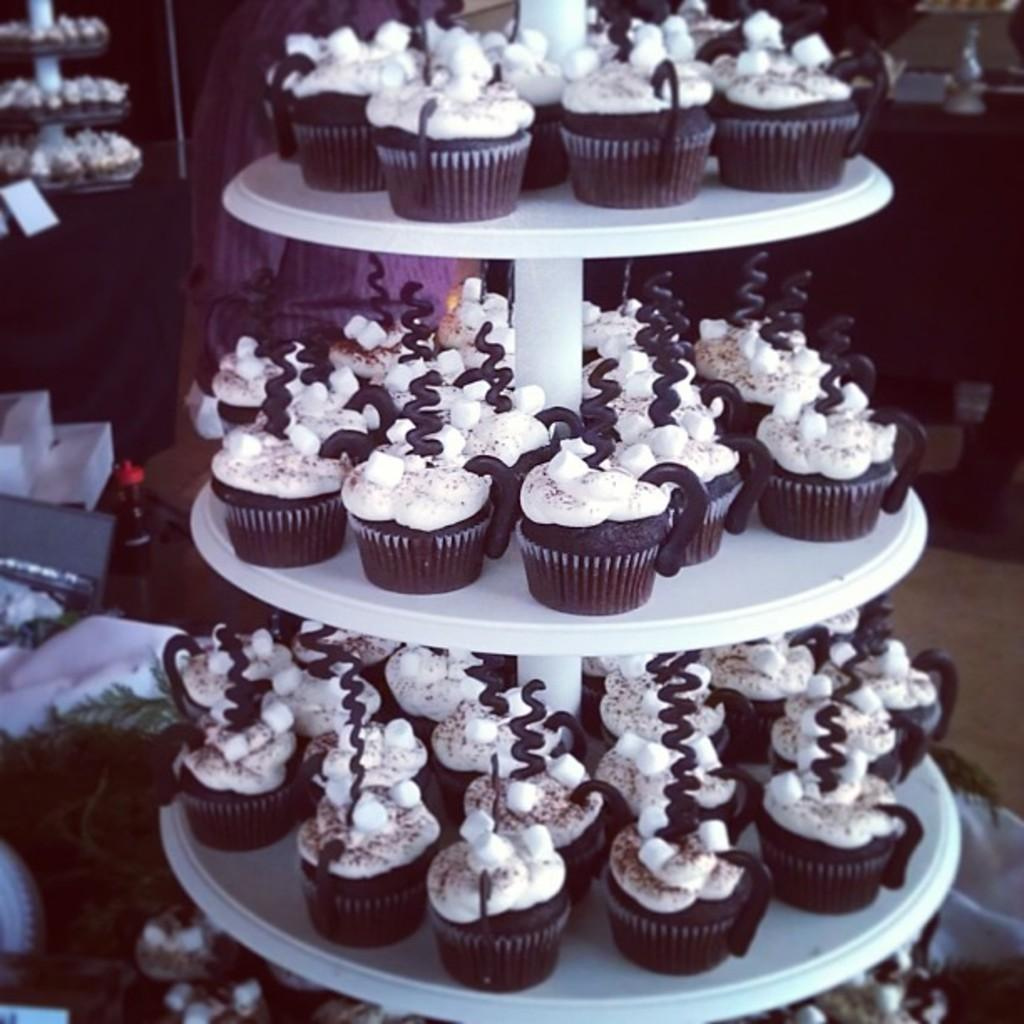What type of food can be seen in the image? There are muffins in the image. What else is present in the image besides the muffins? There is a bottle, a box, and a plant in the image. What is the surface on which the items are placed? The image shows a floor. How would you describe the lighting in the image? The background of the image is dark. What type of paste is being used to create the mist in the image? There is no paste or mist present in the image; it only features muffins, a bottle, a box, a plant, and a floor with a dark background. 